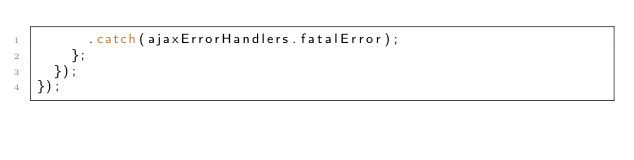<code> <loc_0><loc_0><loc_500><loc_500><_JavaScript_>      .catch(ajaxErrorHandlers.fatalError);
    };
  });
});
</code> 